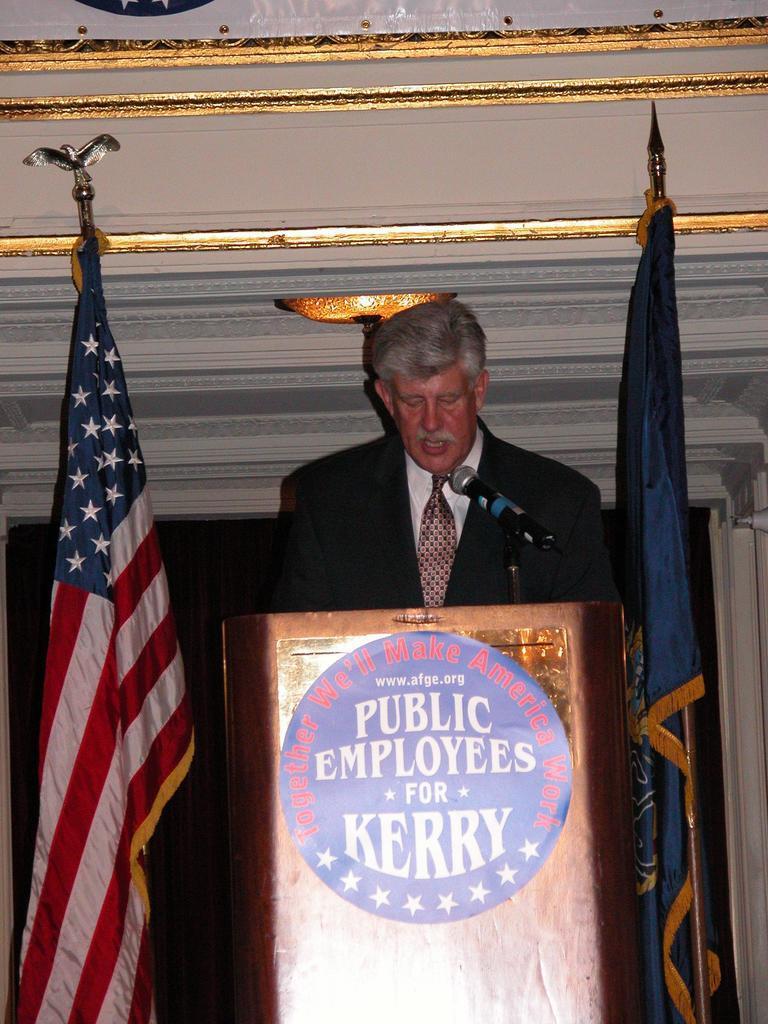Describe this image in one or two sentences. In the picture there is a man standing in front of a table there is a mic in front of him, he is speaking something and on the either side of the man there are two flags, He is wearing a blazer and white shirt and a tie. 